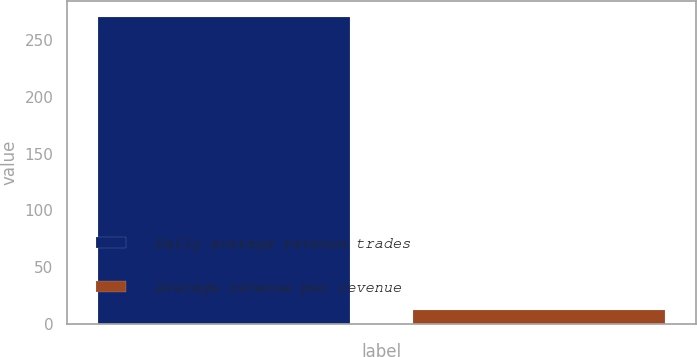<chart> <loc_0><loc_0><loc_500><loc_500><bar_chart><fcel>Daily average revenue trades<fcel>Average revenue per revenue<nl><fcel>270.7<fcel>12.28<nl></chart> 